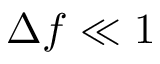<formula> <loc_0><loc_0><loc_500><loc_500>\Delta f \ll 1</formula> 